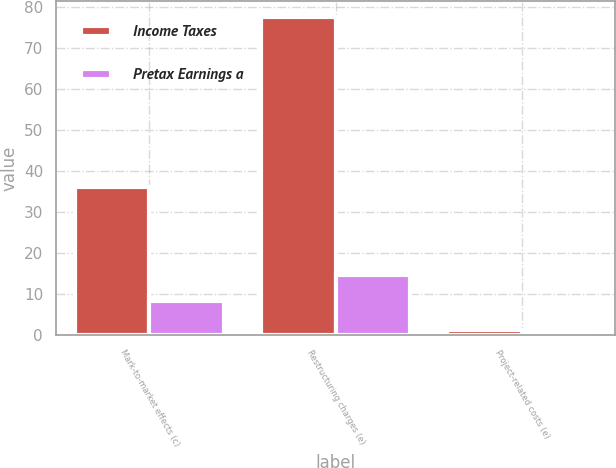<chart> <loc_0><loc_0><loc_500><loc_500><stacked_bar_chart><ecel><fcel>Mark-to-market effects (c)<fcel>Restructuring charges (e)<fcel>Project-related costs (e)<nl><fcel>Income Taxes<fcel>36<fcel>77.6<fcel>1.3<nl><fcel>Pretax Earnings a<fcel>8.3<fcel>14.6<fcel>0.2<nl></chart> 